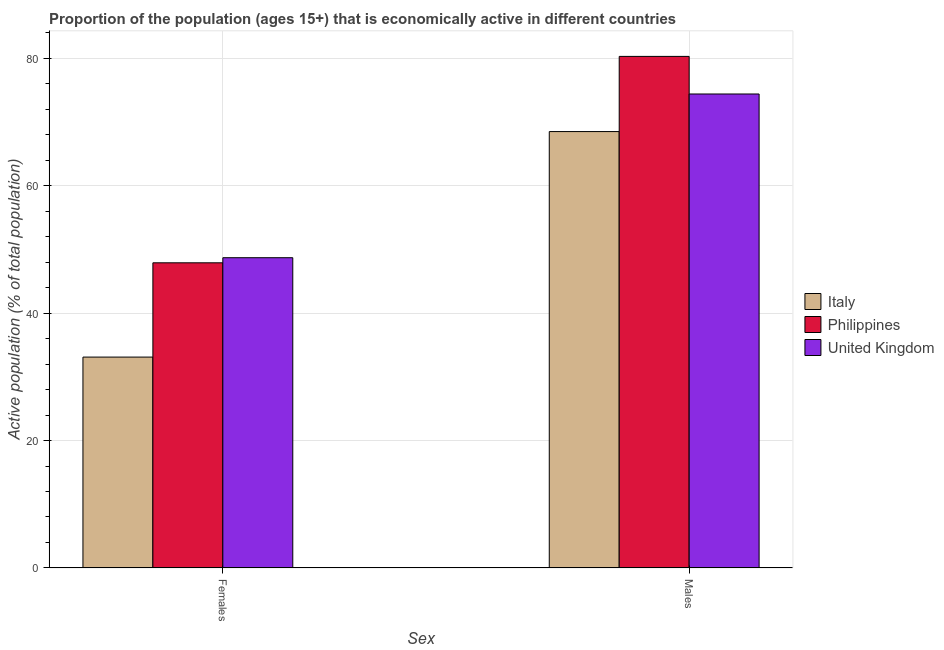Are the number of bars per tick equal to the number of legend labels?
Your response must be concise. Yes. What is the label of the 1st group of bars from the left?
Your response must be concise. Females. What is the percentage of economically active female population in Italy?
Your answer should be compact. 33.1. Across all countries, what is the maximum percentage of economically active female population?
Make the answer very short. 48.7. Across all countries, what is the minimum percentage of economically active female population?
Ensure brevity in your answer.  33.1. In which country was the percentage of economically active male population maximum?
Offer a terse response. Philippines. What is the total percentage of economically active male population in the graph?
Provide a short and direct response. 223.2. What is the difference between the percentage of economically active female population in Italy and that in Philippines?
Offer a terse response. -14.8. What is the difference between the percentage of economically active male population in Philippines and the percentage of economically active female population in United Kingdom?
Keep it short and to the point. 31.6. What is the average percentage of economically active female population per country?
Your answer should be very brief. 43.23. What is the difference between the percentage of economically active male population and percentage of economically active female population in Philippines?
Your response must be concise. 32.4. In how many countries, is the percentage of economically active female population greater than 4 %?
Your answer should be compact. 3. What is the ratio of the percentage of economically active male population in United Kingdom to that in Italy?
Provide a succinct answer. 1.09. Is the percentage of economically active female population in Italy less than that in United Kingdom?
Provide a short and direct response. Yes. What does the 1st bar from the left in Females represents?
Ensure brevity in your answer.  Italy. How many bars are there?
Your answer should be compact. 6. How many countries are there in the graph?
Your response must be concise. 3. What is the difference between two consecutive major ticks on the Y-axis?
Give a very brief answer. 20. Does the graph contain grids?
Keep it short and to the point. Yes. How many legend labels are there?
Your response must be concise. 3. How are the legend labels stacked?
Give a very brief answer. Vertical. What is the title of the graph?
Keep it short and to the point. Proportion of the population (ages 15+) that is economically active in different countries. Does "American Samoa" appear as one of the legend labels in the graph?
Make the answer very short. No. What is the label or title of the X-axis?
Give a very brief answer. Sex. What is the label or title of the Y-axis?
Keep it short and to the point. Active population (% of total population). What is the Active population (% of total population) in Italy in Females?
Ensure brevity in your answer.  33.1. What is the Active population (% of total population) in Philippines in Females?
Provide a succinct answer. 47.9. What is the Active population (% of total population) in United Kingdom in Females?
Give a very brief answer. 48.7. What is the Active population (% of total population) of Italy in Males?
Ensure brevity in your answer.  68.5. What is the Active population (% of total population) of Philippines in Males?
Make the answer very short. 80.3. What is the Active population (% of total population) in United Kingdom in Males?
Your answer should be very brief. 74.4. Across all Sex, what is the maximum Active population (% of total population) of Italy?
Offer a terse response. 68.5. Across all Sex, what is the maximum Active population (% of total population) in Philippines?
Your answer should be compact. 80.3. Across all Sex, what is the maximum Active population (% of total population) of United Kingdom?
Offer a terse response. 74.4. Across all Sex, what is the minimum Active population (% of total population) of Italy?
Give a very brief answer. 33.1. Across all Sex, what is the minimum Active population (% of total population) in Philippines?
Offer a terse response. 47.9. Across all Sex, what is the minimum Active population (% of total population) in United Kingdom?
Make the answer very short. 48.7. What is the total Active population (% of total population) in Italy in the graph?
Ensure brevity in your answer.  101.6. What is the total Active population (% of total population) in Philippines in the graph?
Your answer should be compact. 128.2. What is the total Active population (% of total population) in United Kingdom in the graph?
Provide a succinct answer. 123.1. What is the difference between the Active population (% of total population) in Italy in Females and that in Males?
Your answer should be compact. -35.4. What is the difference between the Active population (% of total population) in Philippines in Females and that in Males?
Give a very brief answer. -32.4. What is the difference between the Active population (% of total population) of United Kingdom in Females and that in Males?
Provide a short and direct response. -25.7. What is the difference between the Active population (% of total population) in Italy in Females and the Active population (% of total population) in Philippines in Males?
Make the answer very short. -47.2. What is the difference between the Active population (% of total population) of Italy in Females and the Active population (% of total population) of United Kingdom in Males?
Your answer should be compact. -41.3. What is the difference between the Active population (% of total population) of Philippines in Females and the Active population (% of total population) of United Kingdom in Males?
Your answer should be very brief. -26.5. What is the average Active population (% of total population) in Italy per Sex?
Your answer should be compact. 50.8. What is the average Active population (% of total population) of Philippines per Sex?
Keep it short and to the point. 64.1. What is the average Active population (% of total population) in United Kingdom per Sex?
Your answer should be compact. 61.55. What is the difference between the Active population (% of total population) in Italy and Active population (% of total population) in Philippines in Females?
Keep it short and to the point. -14.8. What is the difference between the Active population (% of total population) of Italy and Active population (% of total population) of United Kingdom in Females?
Keep it short and to the point. -15.6. What is the difference between the Active population (% of total population) of Philippines and Active population (% of total population) of United Kingdom in Females?
Your answer should be very brief. -0.8. What is the difference between the Active population (% of total population) in Philippines and Active population (% of total population) in United Kingdom in Males?
Provide a short and direct response. 5.9. What is the ratio of the Active population (% of total population) of Italy in Females to that in Males?
Make the answer very short. 0.48. What is the ratio of the Active population (% of total population) in Philippines in Females to that in Males?
Your answer should be compact. 0.6. What is the ratio of the Active population (% of total population) of United Kingdom in Females to that in Males?
Your response must be concise. 0.65. What is the difference between the highest and the second highest Active population (% of total population) of Italy?
Your response must be concise. 35.4. What is the difference between the highest and the second highest Active population (% of total population) of Philippines?
Ensure brevity in your answer.  32.4. What is the difference between the highest and the second highest Active population (% of total population) of United Kingdom?
Provide a succinct answer. 25.7. What is the difference between the highest and the lowest Active population (% of total population) of Italy?
Offer a very short reply. 35.4. What is the difference between the highest and the lowest Active population (% of total population) of Philippines?
Provide a short and direct response. 32.4. What is the difference between the highest and the lowest Active population (% of total population) of United Kingdom?
Ensure brevity in your answer.  25.7. 